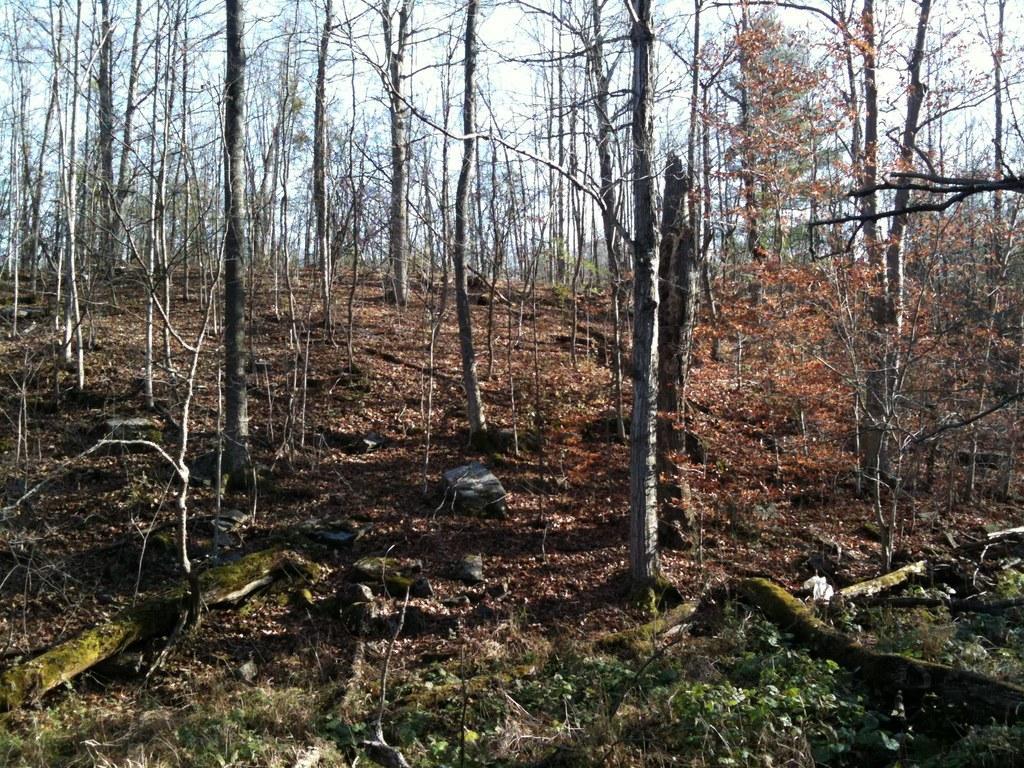Describe this image in one or two sentences. In this picture I can see many trees, plants and grass. At the top there is a sky. 